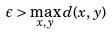Convert formula to latex. <formula><loc_0><loc_0><loc_500><loc_500>\epsilon > \max _ { x , y } d ( x , y )</formula> 